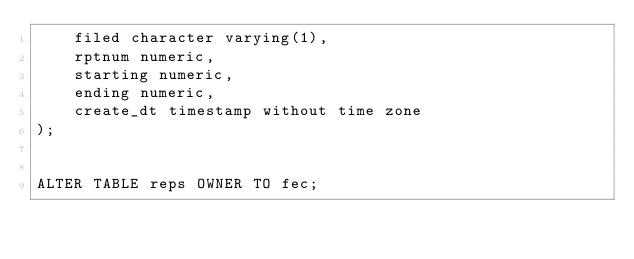Convert code to text. <code><loc_0><loc_0><loc_500><loc_500><_SQL_>    filed character varying(1),
    rptnum numeric,
    starting numeric,
    ending numeric,
    create_dt timestamp without time zone
);


ALTER TABLE reps OWNER TO fec;
</code> 